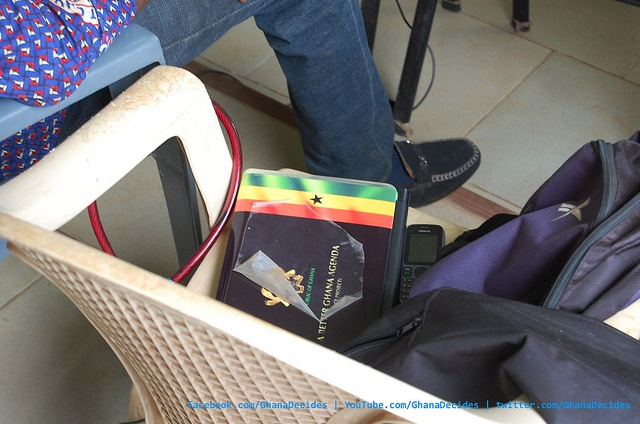Describe the objects in this image and their specific colors. I can see chair in blue, white, and tan tones, people in blue, navy, black, and gray tones, laptop in blue, black, gray, and darkgray tones, book in blue, black, gray, and darkgray tones, and backpack in blue, black, and gray tones in this image. 